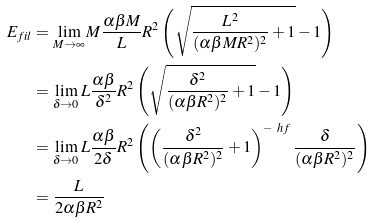<formula> <loc_0><loc_0><loc_500><loc_500>E _ { f i l } & = \lim _ { M \rightarrow \infty } M \frac { \alpha \beta M } { L } R ^ { 2 } \left ( \sqrt { \frac { L ^ { 2 } } { ( \alpha \beta M R ^ { 2 } ) ^ { 2 } } + 1 } - 1 \right ) \\ & = \lim _ { \delta \rightarrow 0 } L \frac { \alpha \beta } { \delta ^ { 2 } } R ^ { 2 } \left ( \sqrt { \frac { \delta ^ { 2 } } { ( \alpha \beta R ^ { 2 } ) ^ { 2 } } + 1 } - 1 \right ) \\ & = \lim _ { \delta \rightarrow 0 } L \frac { \alpha \beta } { 2 \delta } R ^ { 2 } \left ( \left ( \frac { \delta ^ { 2 } } { ( \alpha \beta R ^ { 2 } ) ^ { 2 } } + 1 \right ) ^ { - \ h f } \frac { \delta } { ( \alpha \beta R ^ { 2 } ) ^ { 2 } } \right ) \\ & = \frac { L } { 2 \alpha \beta R ^ { 2 } }</formula> 